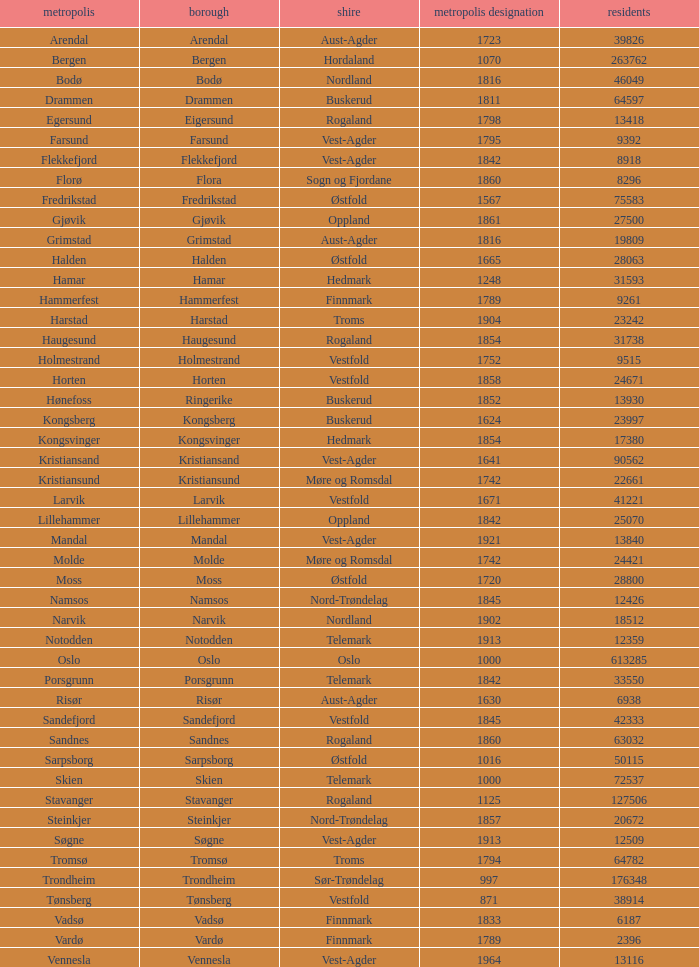What are the cities/towns located in the municipality of Horten? Horten. Give me the full table as a dictionary. {'header': ['metropolis', 'borough', 'shire', 'metropolis designation', 'residents'], 'rows': [['Arendal', 'Arendal', 'Aust-Agder', '1723', '39826'], ['Bergen', 'Bergen', 'Hordaland', '1070', '263762'], ['Bodø', 'Bodø', 'Nordland', '1816', '46049'], ['Drammen', 'Drammen', 'Buskerud', '1811', '64597'], ['Egersund', 'Eigersund', 'Rogaland', '1798', '13418'], ['Farsund', 'Farsund', 'Vest-Agder', '1795', '9392'], ['Flekkefjord', 'Flekkefjord', 'Vest-Agder', '1842', '8918'], ['Florø', 'Flora', 'Sogn og Fjordane', '1860', '8296'], ['Fredrikstad', 'Fredrikstad', 'Østfold', '1567', '75583'], ['Gjøvik', 'Gjøvik', 'Oppland', '1861', '27500'], ['Grimstad', 'Grimstad', 'Aust-Agder', '1816', '19809'], ['Halden', 'Halden', 'Østfold', '1665', '28063'], ['Hamar', 'Hamar', 'Hedmark', '1248', '31593'], ['Hammerfest', 'Hammerfest', 'Finnmark', '1789', '9261'], ['Harstad', 'Harstad', 'Troms', '1904', '23242'], ['Haugesund', 'Haugesund', 'Rogaland', '1854', '31738'], ['Holmestrand', 'Holmestrand', 'Vestfold', '1752', '9515'], ['Horten', 'Horten', 'Vestfold', '1858', '24671'], ['Hønefoss', 'Ringerike', 'Buskerud', '1852', '13930'], ['Kongsberg', 'Kongsberg', 'Buskerud', '1624', '23997'], ['Kongsvinger', 'Kongsvinger', 'Hedmark', '1854', '17380'], ['Kristiansand', 'Kristiansand', 'Vest-Agder', '1641', '90562'], ['Kristiansund', 'Kristiansund', 'Møre og Romsdal', '1742', '22661'], ['Larvik', 'Larvik', 'Vestfold', '1671', '41221'], ['Lillehammer', 'Lillehammer', 'Oppland', '1842', '25070'], ['Mandal', 'Mandal', 'Vest-Agder', '1921', '13840'], ['Molde', 'Molde', 'Møre og Romsdal', '1742', '24421'], ['Moss', 'Moss', 'Østfold', '1720', '28800'], ['Namsos', 'Namsos', 'Nord-Trøndelag', '1845', '12426'], ['Narvik', 'Narvik', 'Nordland', '1902', '18512'], ['Notodden', 'Notodden', 'Telemark', '1913', '12359'], ['Oslo', 'Oslo', 'Oslo', '1000', '613285'], ['Porsgrunn', 'Porsgrunn', 'Telemark', '1842', '33550'], ['Risør', 'Risør', 'Aust-Agder', '1630', '6938'], ['Sandefjord', 'Sandefjord', 'Vestfold', '1845', '42333'], ['Sandnes', 'Sandnes', 'Rogaland', '1860', '63032'], ['Sarpsborg', 'Sarpsborg', 'Østfold', '1016', '50115'], ['Skien', 'Skien', 'Telemark', '1000', '72537'], ['Stavanger', 'Stavanger', 'Rogaland', '1125', '127506'], ['Steinkjer', 'Steinkjer', 'Nord-Trøndelag', '1857', '20672'], ['Søgne', 'Søgne', 'Vest-Agder', '1913', '12509'], ['Tromsø', 'Tromsø', 'Troms', '1794', '64782'], ['Trondheim', 'Trondheim', 'Sør-Trøndelag', '997', '176348'], ['Tønsberg', 'Tønsberg', 'Vestfold', '871', '38914'], ['Vadsø', 'Vadsø', 'Finnmark', '1833', '6187'], ['Vardø', 'Vardø', 'Finnmark', '1789', '2396'], ['Vennesla', 'Vennesla', 'Vest-Agder', '1964', '13116']]} 